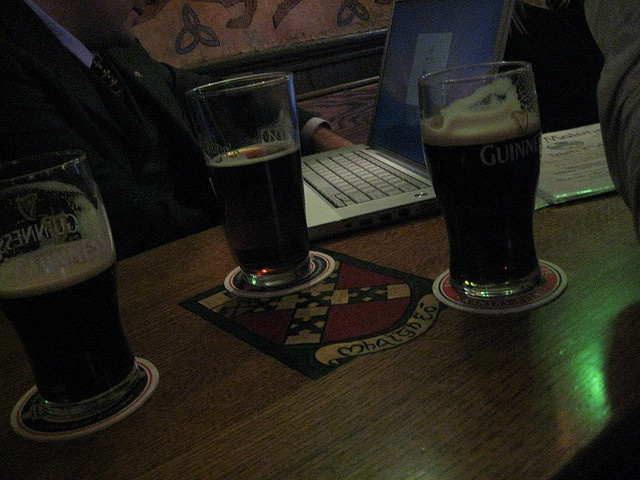Describe the objects in this image and their specific colors. I can see people in black, maroon, and gray tones, cup in black and gray tones, cup in black, darkgreen, and gray tones, laptop in black and gray tones, and cup in black, gray, darkgreen, and maroon tones in this image. 